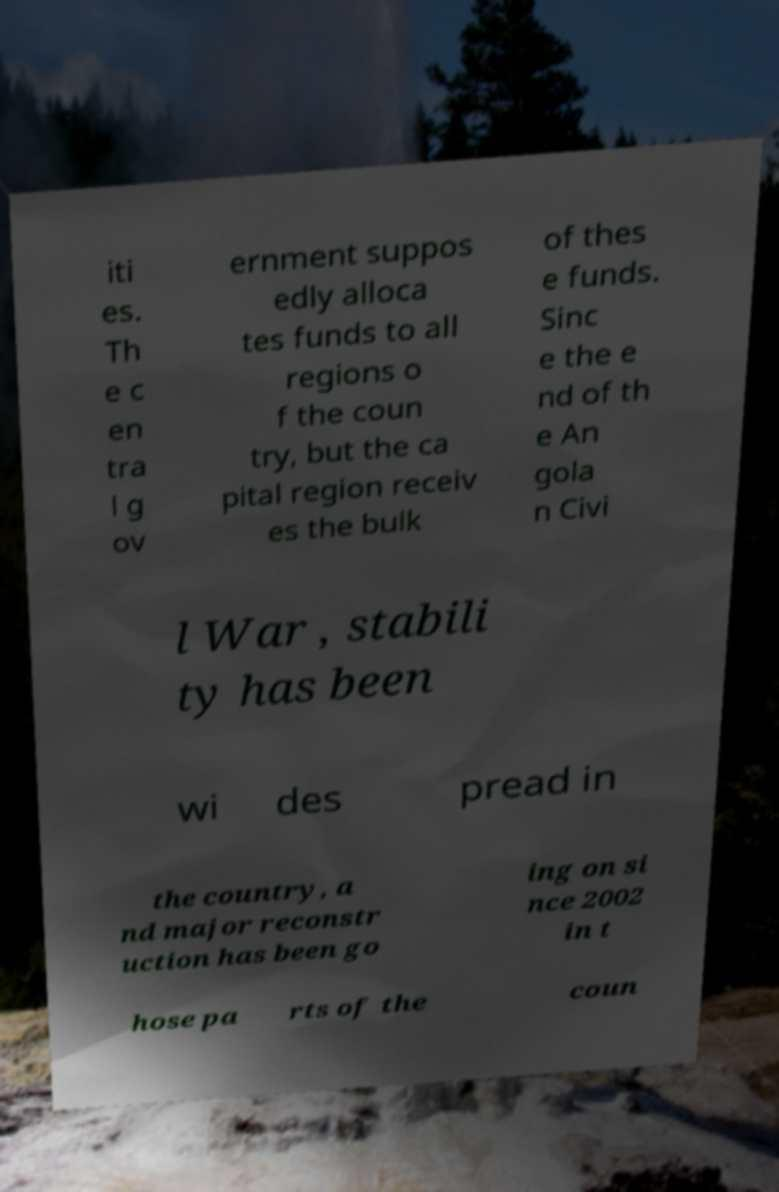What messages or text are displayed in this image? I need them in a readable, typed format. iti es. Th e c en tra l g ov ernment suppos edly alloca tes funds to all regions o f the coun try, but the ca pital region receiv es the bulk of thes e funds. Sinc e the e nd of th e An gola n Civi l War , stabili ty has been wi des pread in the country, a nd major reconstr uction has been go ing on si nce 2002 in t hose pa rts of the coun 